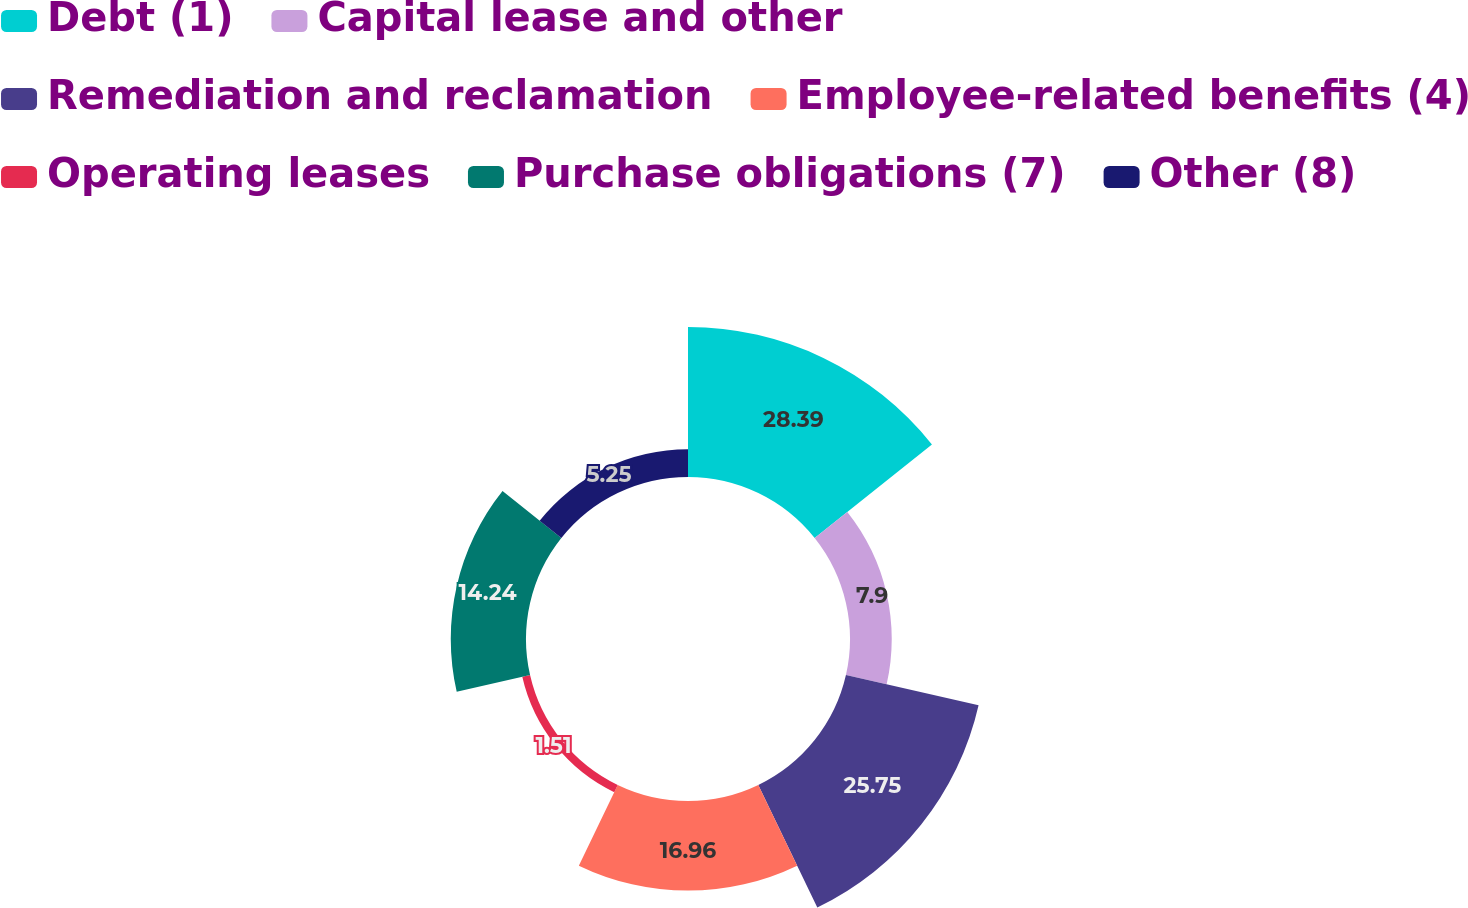Convert chart. <chart><loc_0><loc_0><loc_500><loc_500><pie_chart><fcel>Debt (1)<fcel>Capital lease and other<fcel>Remediation and reclamation<fcel>Employee-related benefits (4)<fcel>Operating leases<fcel>Purchase obligations (7)<fcel>Other (8)<nl><fcel>28.39%<fcel>7.9%<fcel>25.75%<fcel>16.96%<fcel>1.51%<fcel>14.24%<fcel>5.25%<nl></chart> 